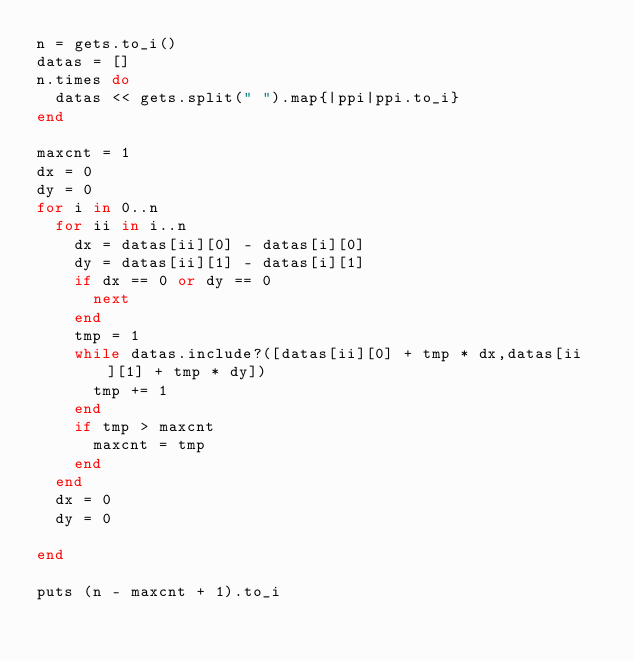<code> <loc_0><loc_0><loc_500><loc_500><_Ruby_>n = gets.to_i()
datas = []
n.times do
  datas << gets.split(" ").map{|ppi|ppi.to_i}
end

maxcnt = 1
dx = 0
dy = 0
for i in 0..n
  for ii in i..n
    dx = datas[ii][0] - datas[i][0]
    dy = datas[ii][1] - datas[i][1]
    if dx == 0 or dy == 0
      next
    end
    tmp = 1
    while datas.include?([datas[ii][0] + tmp * dx,datas[ii][1] + tmp * dy])
      tmp += 1
    end
    if tmp > maxcnt
      maxcnt = tmp
    end
  end
  dx = 0
  dy = 0
  
end

puts (n - maxcnt + 1).to_i</code> 